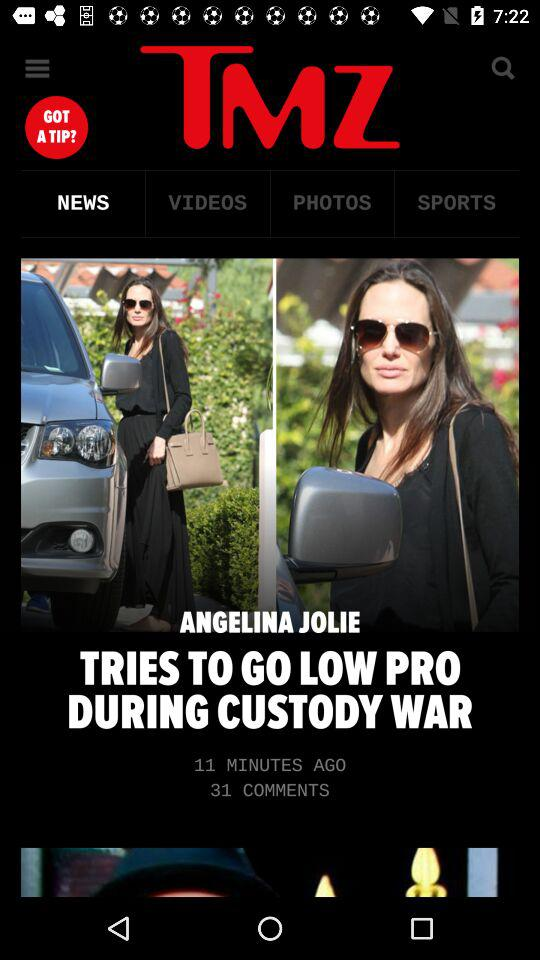How many comments on the news? There are 31 comments on the news. 